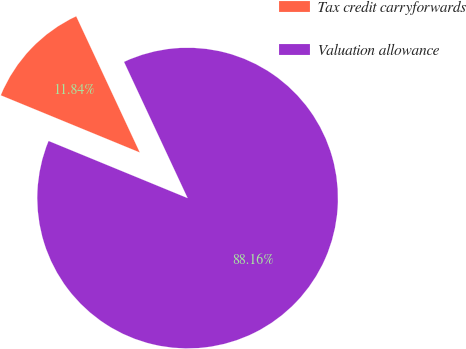Convert chart to OTSL. <chart><loc_0><loc_0><loc_500><loc_500><pie_chart><fcel>Tax credit carryforwards<fcel>Valuation allowance<nl><fcel>11.84%<fcel>88.16%<nl></chart> 